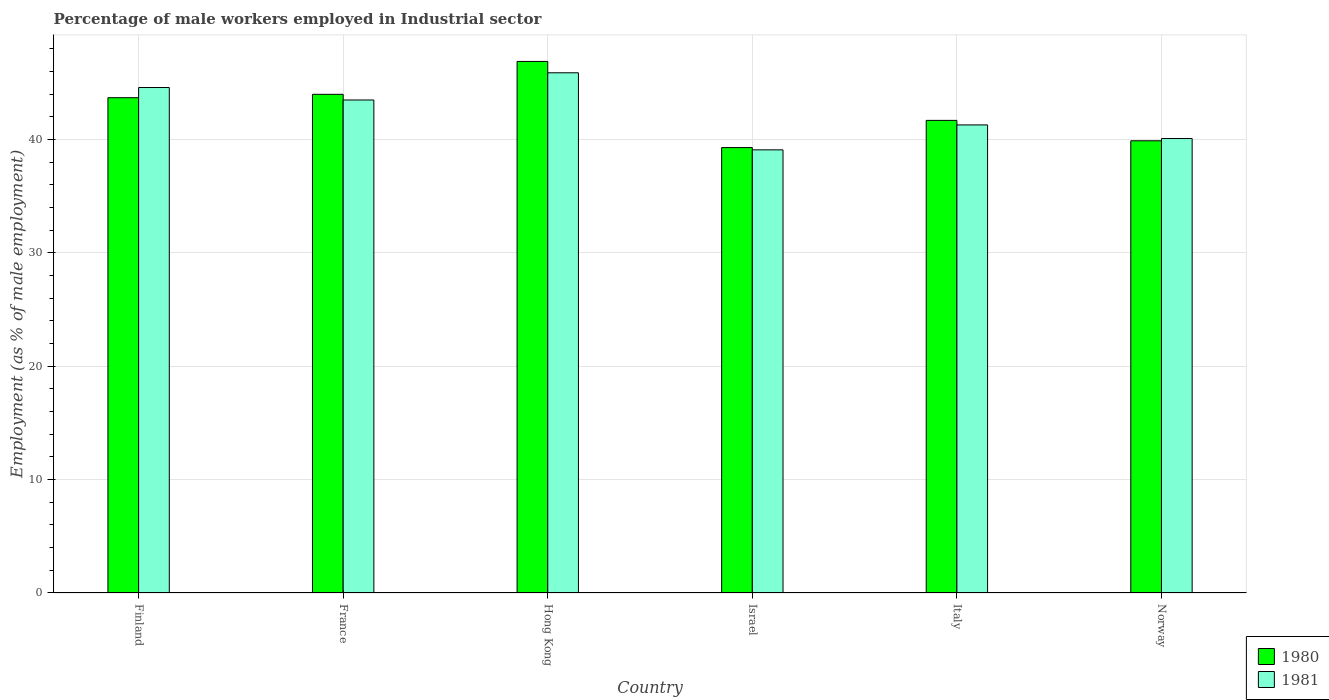How many different coloured bars are there?
Ensure brevity in your answer.  2. How many groups of bars are there?
Give a very brief answer. 6. Are the number of bars per tick equal to the number of legend labels?
Provide a short and direct response. Yes. Are the number of bars on each tick of the X-axis equal?
Give a very brief answer. Yes. How many bars are there on the 4th tick from the left?
Keep it short and to the point. 2. How many bars are there on the 1st tick from the right?
Make the answer very short. 2. What is the label of the 4th group of bars from the left?
Your answer should be very brief. Israel. What is the percentage of male workers employed in Industrial sector in 1980 in Israel?
Ensure brevity in your answer.  39.3. Across all countries, what is the maximum percentage of male workers employed in Industrial sector in 1981?
Your answer should be compact. 45.9. Across all countries, what is the minimum percentage of male workers employed in Industrial sector in 1980?
Offer a terse response. 39.3. In which country was the percentage of male workers employed in Industrial sector in 1980 maximum?
Provide a short and direct response. Hong Kong. What is the total percentage of male workers employed in Industrial sector in 1981 in the graph?
Make the answer very short. 254.5. What is the difference between the percentage of male workers employed in Industrial sector in 1980 in Italy and that in Norway?
Provide a short and direct response. 1.8. What is the difference between the percentage of male workers employed in Industrial sector in 1981 in Finland and the percentage of male workers employed in Industrial sector in 1980 in Israel?
Make the answer very short. 5.3. What is the average percentage of male workers employed in Industrial sector in 1981 per country?
Provide a succinct answer. 42.42. What is the difference between the percentage of male workers employed in Industrial sector of/in 1980 and percentage of male workers employed in Industrial sector of/in 1981 in Israel?
Ensure brevity in your answer.  0.2. In how many countries, is the percentage of male workers employed in Industrial sector in 1981 greater than 4 %?
Give a very brief answer. 6. What is the ratio of the percentage of male workers employed in Industrial sector in 1981 in France to that in Italy?
Your response must be concise. 1.05. What is the difference between the highest and the second highest percentage of male workers employed in Industrial sector in 1980?
Provide a succinct answer. -0.3. What is the difference between the highest and the lowest percentage of male workers employed in Industrial sector in 1980?
Your answer should be very brief. 7.6. Is the sum of the percentage of male workers employed in Industrial sector in 1980 in Finland and Israel greater than the maximum percentage of male workers employed in Industrial sector in 1981 across all countries?
Your answer should be very brief. Yes. How many bars are there?
Make the answer very short. 12. Are all the bars in the graph horizontal?
Provide a short and direct response. No. How many countries are there in the graph?
Your response must be concise. 6. Does the graph contain any zero values?
Your response must be concise. No. Does the graph contain grids?
Your answer should be very brief. Yes. Where does the legend appear in the graph?
Provide a short and direct response. Bottom right. What is the title of the graph?
Provide a succinct answer. Percentage of male workers employed in Industrial sector. Does "1961" appear as one of the legend labels in the graph?
Give a very brief answer. No. What is the label or title of the Y-axis?
Ensure brevity in your answer.  Employment (as % of male employment). What is the Employment (as % of male employment) in 1980 in Finland?
Your response must be concise. 43.7. What is the Employment (as % of male employment) in 1981 in Finland?
Make the answer very short. 44.6. What is the Employment (as % of male employment) of 1981 in France?
Keep it short and to the point. 43.5. What is the Employment (as % of male employment) of 1980 in Hong Kong?
Make the answer very short. 46.9. What is the Employment (as % of male employment) of 1981 in Hong Kong?
Offer a very short reply. 45.9. What is the Employment (as % of male employment) of 1980 in Israel?
Offer a very short reply. 39.3. What is the Employment (as % of male employment) in 1981 in Israel?
Offer a very short reply. 39.1. What is the Employment (as % of male employment) in 1980 in Italy?
Provide a short and direct response. 41.7. What is the Employment (as % of male employment) in 1981 in Italy?
Provide a short and direct response. 41.3. What is the Employment (as % of male employment) of 1980 in Norway?
Your answer should be very brief. 39.9. What is the Employment (as % of male employment) of 1981 in Norway?
Your answer should be compact. 40.1. Across all countries, what is the maximum Employment (as % of male employment) of 1980?
Keep it short and to the point. 46.9. Across all countries, what is the maximum Employment (as % of male employment) of 1981?
Make the answer very short. 45.9. Across all countries, what is the minimum Employment (as % of male employment) of 1980?
Provide a succinct answer. 39.3. Across all countries, what is the minimum Employment (as % of male employment) of 1981?
Ensure brevity in your answer.  39.1. What is the total Employment (as % of male employment) in 1980 in the graph?
Provide a succinct answer. 255.5. What is the total Employment (as % of male employment) of 1981 in the graph?
Your answer should be very brief. 254.5. What is the difference between the Employment (as % of male employment) of 1981 in Finland and that in France?
Provide a succinct answer. 1.1. What is the difference between the Employment (as % of male employment) of 1980 in Finland and that in Hong Kong?
Ensure brevity in your answer.  -3.2. What is the difference between the Employment (as % of male employment) of 1981 in Finland and that in Hong Kong?
Your response must be concise. -1.3. What is the difference between the Employment (as % of male employment) in 1981 in Finland and that in Israel?
Offer a very short reply. 5.5. What is the difference between the Employment (as % of male employment) in 1980 in Finland and that in Italy?
Offer a very short reply. 2. What is the difference between the Employment (as % of male employment) in 1981 in Finland and that in Norway?
Your answer should be compact. 4.5. What is the difference between the Employment (as % of male employment) of 1980 in France and that in Hong Kong?
Ensure brevity in your answer.  -2.9. What is the difference between the Employment (as % of male employment) in 1980 in France and that in Israel?
Provide a short and direct response. 4.7. What is the difference between the Employment (as % of male employment) in 1981 in France and that in Israel?
Make the answer very short. 4.4. What is the difference between the Employment (as % of male employment) of 1980 in France and that in Italy?
Keep it short and to the point. 2.3. What is the difference between the Employment (as % of male employment) in 1981 in Hong Kong and that in Italy?
Your response must be concise. 4.6. What is the difference between the Employment (as % of male employment) of 1981 in Hong Kong and that in Norway?
Provide a succinct answer. 5.8. What is the difference between the Employment (as % of male employment) of 1980 in Israel and that in Norway?
Give a very brief answer. -0.6. What is the difference between the Employment (as % of male employment) of 1980 in Italy and that in Norway?
Your answer should be compact. 1.8. What is the difference between the Employment (as % of male employment) in 1980 in Finland and the Employment (as % of male employment) in 1981 in Israel?
Offer a very short reply. 4.6. What is the difference between the Employment (as % of male employment) in 1980 in France and the Employment (as % of male employment) in 1981 in Norway?
Your answer should be compact. 3.9. What is the difference between the Employment (as % of male employment) in 1980 in Hong Kong and the Employment (as % of male employment) in 1981 in Israel?
Offer a very short reply. 7.8. What is the difference between the Employment (as % of male employment) in 1980 in Hong Kong and the Employment (as % of male employment) in 1981 in Italy?
Give a very brief answer. 5.6. What is the difference between the Employment (as % of male employment) of 1980 in Israel and the Employment (as % of male employment) of 1981 in Norway?
Provide a short and direct response. -0.8. What is the difference between the Employment (as % of male employment) in 1980 in Italy and the Employment (as % of male employment) in 1981 in Norway?
Your response must be concise. 1.6. What is the average Employment (as % of male employment) in 1980 per country?
Your answer should be compact. 42.58. What is the average Employment (as % of male employment) in 1981 per country?
Keep it short and to the point. 42.42. What is the difference between the Employment (as % of male employment) of 1980 and Employment (as % of male employment) of 1981 in Finland?
Provide a succinct answer. -0.9. What is the difference between the Employment (as % of male employment) of 1980 and Employment (as % of male employment) of 1981 in France?
Provide a succinct answer. 0.5. What is the difference between the Employment (as % of male employment) in 1980 and Employment (as % of male employment) in 1981 in Hong Kong?
Offer a terse response. 1. What is the ratio of the Employment (as % of male employment) in 1980 in Finland to that in France?
Provide a succinct answer. 0.99. What is the ratio of the Employment (as % of male employment) of 1981 in Finland to that in France?
Keep it short and to the point. 1.03. What is the ratio of the Employment (as % of male employment) of 1980 in Finland to that in Hong Kong?
Provide a succinct answer. 0.93. What is the ratio of the Employment (as % of male employment) of 1981 in Finland to that in Hong Kong?
Provide a short and direct response. 0.97. What is the ratio of the Employment (as % of male employment) in 1980 in Finland to that in Israel?
Keep it short and to the point. 1.11. What is the ratio of the Employment (as % of male employment) of 1981 in Finland to that in Israel?
Ensure brevity in your answer.  1.14. What is the ratio of the Employment (as % of male employment) in 1980 in Finland to that in Italy?
Ensure brevity in your answer.  1.05. What is the ratio of the Employment (as % of male employment) of 1981 in Finland to that in Italy?
Offer a very short reply. 1.08. What is the ratio of the Employment (as % of male employment) of 1980 in Finland to that in Norway?
Ensure brevity in your answer.  1.1. What is the ratio of the Employment (as % of male employment) of 1981 in Finland to that in Norway?
Keep it short and to the point. 1.11. What is the ratio of the Employment (as % of male employment) in 1980 in France to that in Hong Kong?
Ensure brevity in your answer.  0.94. What is the ratio of the Employment (as % of male employment) in 1981 in France to that in Hong Kong?
Offer a terse response. 0.95. What is the ratio of the Employment (as % of male employment) in 1980 in France to that in Israel?
Keep it short and to the point. 1.12. What is the ratio of the Employment (as % of male employment) of 1981 in France to that in Israel?
Provide a succinct answer. 1.11. What is the ratio of the Employment (as % of male employment) in 1980 in France to that in Italy?
Give a very brief answer. 1.06. What is the ratio of the Employment (as % of male employment) in 1981 in France to that in Italy?
Make the answer very short. 1.05. What is the ratio of the Employment (as % of male employment) of 1980 in France to that in Norway?
Offer a terse response. 1.1. What is the ratio of the Employment (as % of male employment) in 1981 in France to that in Norway?
Give a very brief answer. 1.08. What is the ratio of the Employment (as % of male employment) of 1980 in Hong Kong to that in Israel?
Give a very brief answer. 1.19. What is the ratio of the Employment (as % of male employment) of 1981 in Hong Kong to that in Israel?
Make the answer very short. 1.17. What is the ratio of the Employment (as % of male employment) of 1980 in Hong Kong to that in Italy?
Offer a terse response. 1.12. What is the ratio of the Employment (as % of male employment) of 1981 in Hong Kong to that in Italy?
Make the answer very short. 1.11. What is the ratio of the Employment (as % of male employment) in 1980 in Hong Kong to that in Norway?
Ensure brevity in your answer.  1.18. What is the ratio of the Employment (as % of male employment) of 1981 in Hong Kong to that in Norway?
Make the answer very short. 1.14. What is the ratio of the Employment (as % of male employment) in 1980 in Israel to that in Italy?
Ensure brevity in your answer.  0.94. What is the ratio of the Employment (as % of male employment) of 1981 in Israel to that in Italy?
Keep it short and to the point. 0.95. What is the ratio of the Employment (as % of male employment) in 1981 in Israel to that in Norway?
Provide a short and direct response. 0.98. What is the ratio of the Employment (as % of male employment) in 1980 in Italy to that in Norway?
Provide a short and direct response. 1.05. What is the ratio of the Employment (as % of male employment) of 1981 in Italy to that in Norway?
Your answer should be compact. 1.03. What is the difference between the highest and the second highest Employment (as % of male employment) of 1980?
Provide a short and direct response. 2.9. What is the difference between the highest and the second highest Employment (as % of male employment) of 1981?
Keep it short and to the point. 1.3. 